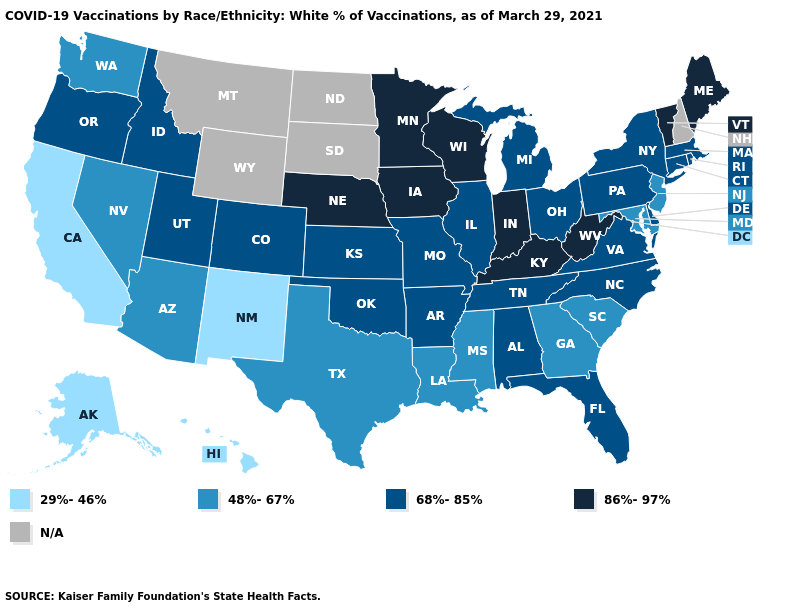What is the value of Washington?
Answer briefly. 48%-67%. What is the value of Pennsylvania?
Short answer required. 68%-85%. Does the first symbol in the legend represent the smallest category?
Give a very brief answer. Yes. Name the states that have a value in the range 68%-85%?
Short answer required. Alabama, Arkansas, Colorado, Connecticut, Delaware, Florida, Idaho, Illinois, Kansas, Massachusetts, Michigan, Missouri, New York, North Carolina, Ohio, Oklahoma, Oregon, Pennsylvania, Rhode Island, Tennessee, Utah, Virginia. Name the states that have a value in the range N/A?
Short answer required. Montana, New Hampshire, North Dakota, South Dakota, Wyoming. Name the states that have a value in the range 48%-67%?
Be succinct. Arizona, Georgia, Louisiana, Maryland, Mississippi, Nevada, New Jersey, South Carolina, Texas, Washington. Does Michigan have the highest value in the USA?
Keep it brief. No. Does Alabama have the highest value in the USA?
Short answer required. No. What is the value of Indiana?
Answer briefly. 86%-97%. What is the value of Maryland?
Keep it brief. 48%-67%. Which states hav the highest value in the South?
Answer briefly. Kentucky, West Virginia. Name the states that have a value in the range N/A?
Short answer required. Montana, New Hampshire, North Dakota, South Dakota, Wyoming. Does Colorado have the highest value in the USA?
Write a very short answer. No. Name the states that have a value in the range N/A?
Concise answer only. Montana, New Hampshire, North Dakota, South Dakota, Wyoming. 